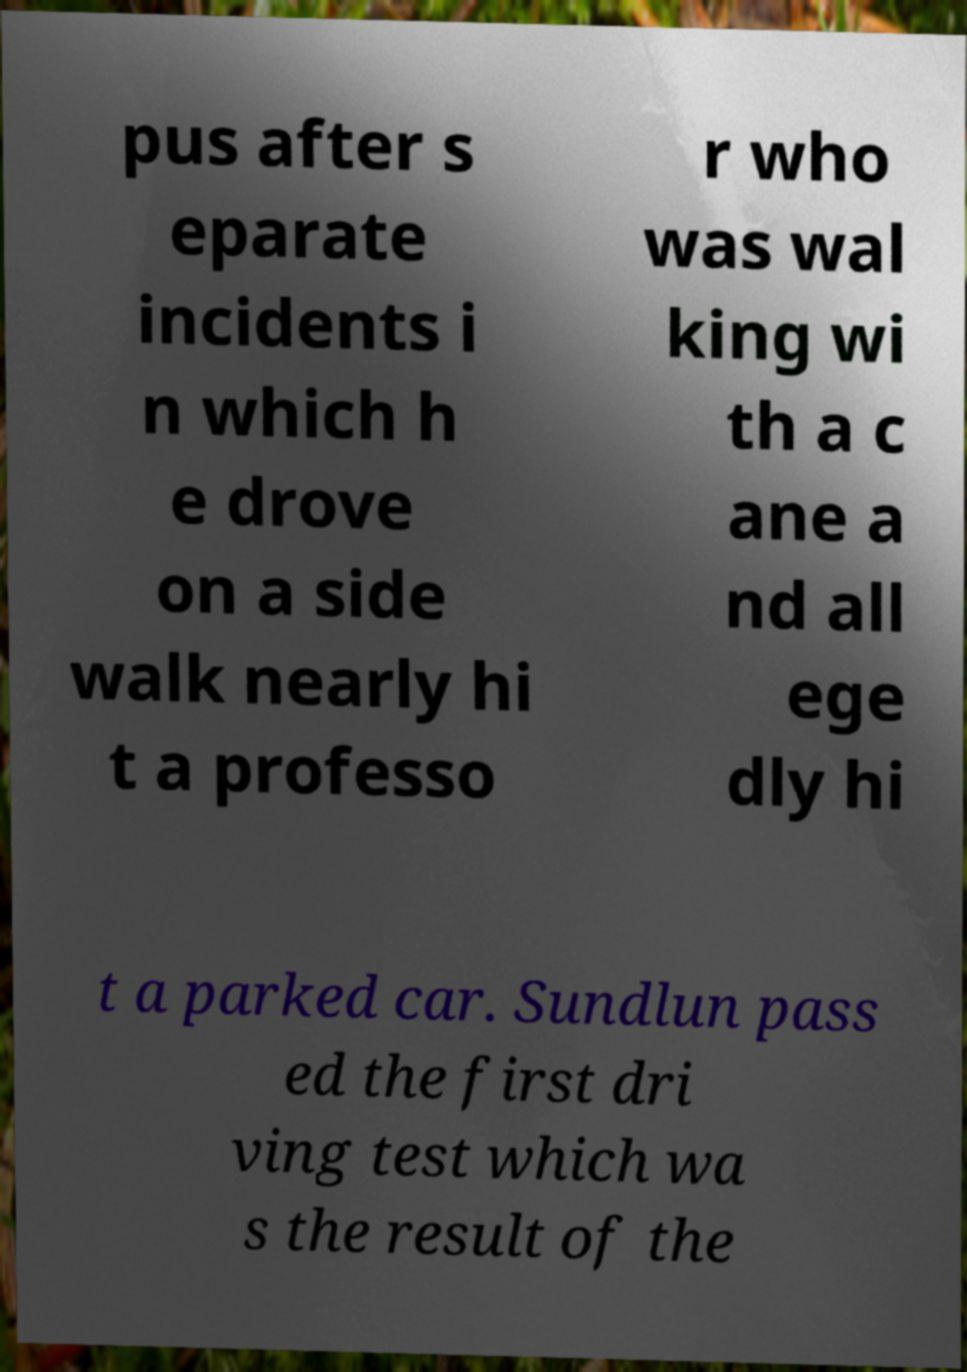Could you assist in decoding the text presented in this image and type it out clearly? pus after s eparate incidents i n which h e drove on a side walk nearly hi t a professo r who was wal king wi th a c ane a nd all ege dly hi t a parked car. Sundlun pass ed the first dri ving test which wa s the result of the 